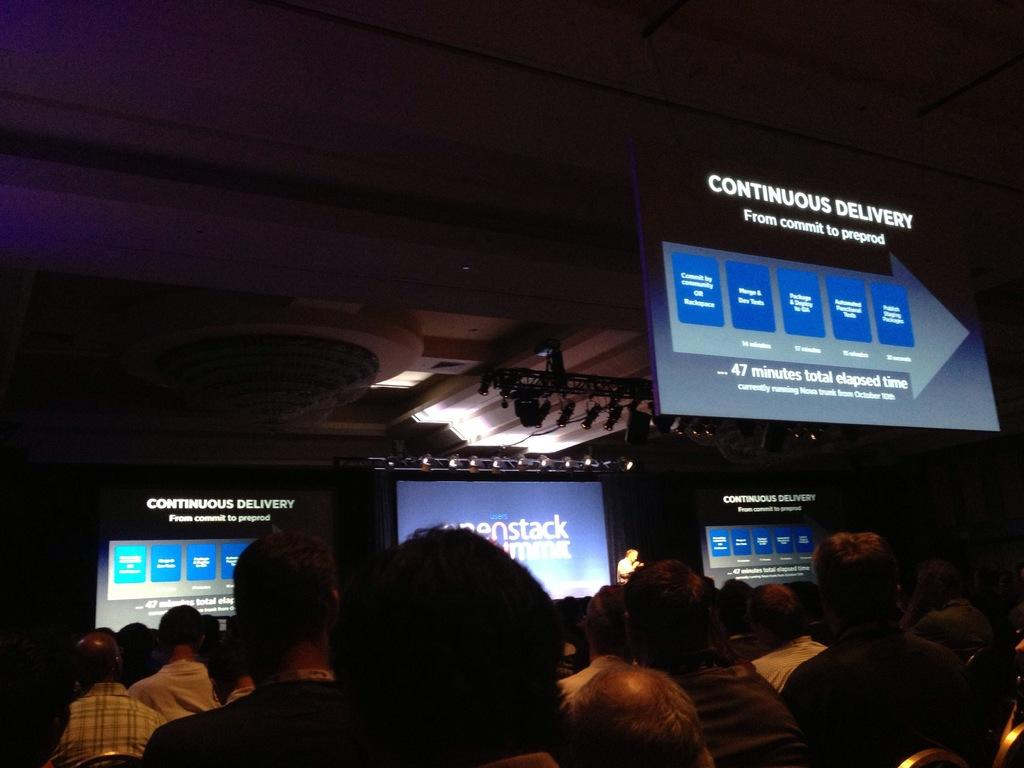What can be seen in the image related to people? There are persons wearing clothes in the image. What objects are located in the middle of the image? There are monitors in the middle of the image. What is visible at the top of the image? There is a ceiling at the top of the image. What type of competition is taking place in the image? There is no competition present in the image. Can you see a monkey supporting the persons in the image? There is no monkey present in the image. 